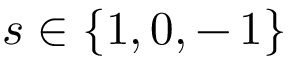<formula> <loc_0><loc_0><loc_500><loc_500>s \in \{ 1 , 0 , - \, 1 \}</formula> 